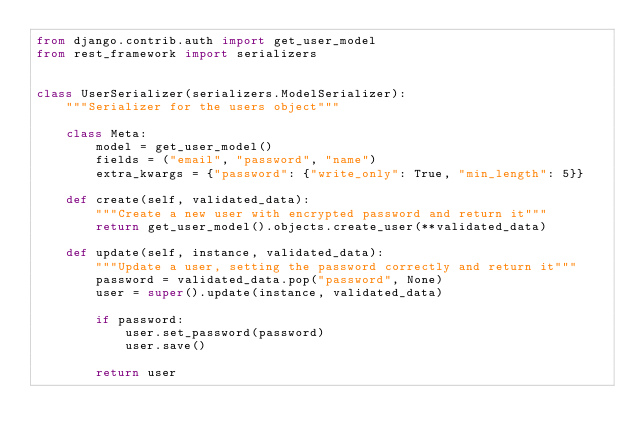Convert code to text. <code><loc_0><loc_0><loc_500><loc_500><_Python_>from django.contrib.auth import get_user_model
from rest_framework import serializers


class UserSerializer(serializers.ModelSerializer):
    """Serializer for the users object"""

    class Meta:
        model = get_user_model()
        fields = ("email", "password", "name")
        extra_kwargs = {"password": {"write_only": True, "min_length": 5}}

    def create(self, validated_data):
        """Create a new user with encrypted password and return it"""
        return get_user_model().objects.create_user(**validated_data)

    def update(self, instance, validated_data):
        """Update a user, setting the password correctly and return it"""
        password = validated_data.pop("password", None)
        user = super().update(instance, validated_data)

        if password:
            user.set_password(password)
            user.save()

        return user
</code> 